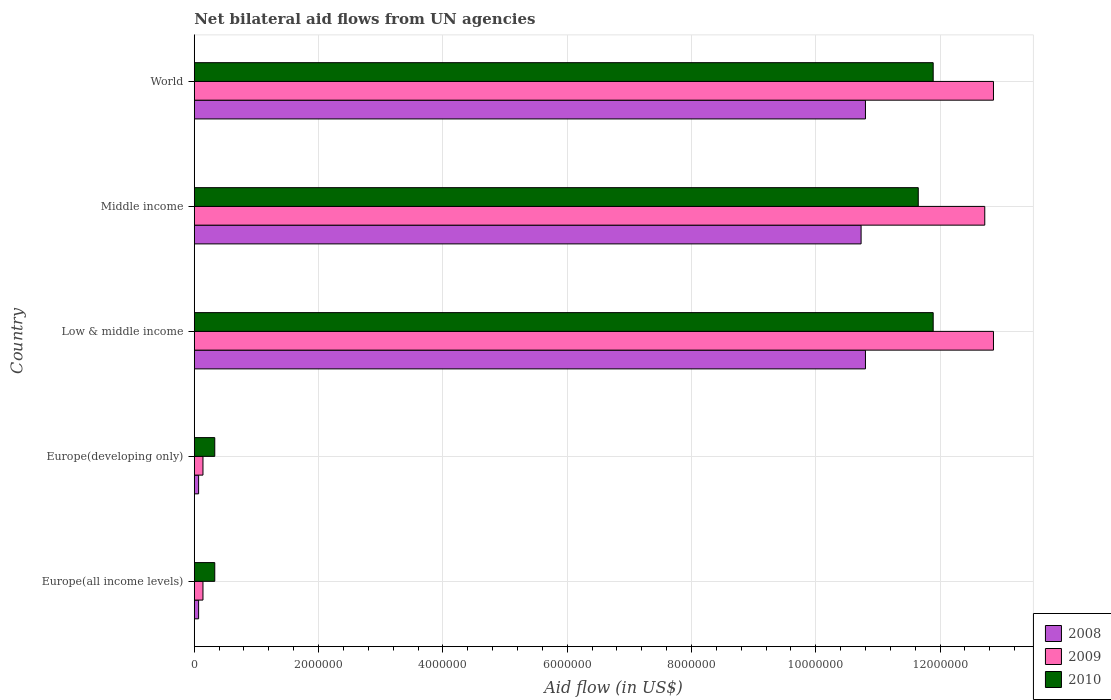How many different coloured bars are there?
Offer a very short reply. 3. Are the number of bars on each tick of the Y-axis equal?
Offer a terse response. Yes. How many bars are there on the 4th tick from the top?
Offer a terse response. 3. How many bars are there on the 4th tick from the bottom?
Give a very brief answer. 3. What is the label of the 4th group of bars from the top?
Your answer should be compact. Europe(developing only). In how many cases, is the number of bars for a given country not equal to the number of legend labels?
Provide a short and direct response. 0. What is the net bilateral aid flow in 2010 in Low & middle income?
Provide a short and direct response. 1.19e+07. Across all countries, what is the maximum net bilateral aid flow in 2009?
Your answer should be compact. 1.29e+07. Across all countries, what is the minimum net bilateral aid flow in 2009?
Provide a short and direct response. 1.40e+05. In which country was the net bilateral aid flow in 2008 maximum?
Your answer should be compact. Low & middle income. In which country was the net bilateral aid flow in 2010 minimum?
Make the answer very short. Europe(all income levels). What is the total net bilateral aid flow in 2009 in the graph?
Your response must be concise. 3.87e+07. What is the difference between the net bilateral aid flow in 2008 in Europe(all income levels) and that in Europe(developing only)?
Keep it short and to the point. 0. What is the difference between the net bilateral aid flow in 2009 in Europe(all income levels) and the net bilateral aid flow in 2008 in Low & middle income?
Provide a succinct answer. -1.07e+07. What is the average net bilateral aid flow in 2009 per country?
Your response must be concise. 7.74e+06. What is the difference between the net bilateral aid flow in 2008 and net bilateral aid flow in 2010 in World?
Provide a succinct answer. -1.09e+06. In how many countries, is the net bilateral aid flow in 2008 greater than 11200000 US$?
Provide a short and direct response. 0. What is the ratio of the net bilateral aid flow in 2009 in Europe(developing only) to that in Low & middle income?
Make the answer very short. 0.01. Is the difference between the net bilateral aid flow in 2008 in Europe(all income levels) and Europe(developing only) greater than the difference between the net bilateral aid flow in 2010 in Europe(all income levels) and Europe(developing only)?
Give a very brief answer. No. What is the difference between the highest and the second highest net bilateral aid flow in 2010?
Offer a very short reply. 0. What is the difference between the highest and the lowest net bilateral aid flow in 2009?
Your answer should be compact. 1.27e+07. In how many countries, is the net bilateral aid flow in 2008 greater than the average net bilateral aid flow in 2008 taken over all countries?
Offer a very short reply. 3. What does the 2nd bar from the top in Low & middle income represents?
Your answer should be compact. 2009. What does the 1st bar from the bottom in Middle income represents?
Give a very brief answer. 2008. How many bars are there?
Make the answer very short. 15. Are all the bars in the graph horizontal?
Make the answer very short. Yes. Are the values on the major ticks of X-axis written in scientific E-notation?
Make the answer very short. No. Does the graph contain grids?
Your answer should be compact. Yes. Where does the legend appear in the graph?
Your answer should be very brief. Bottom right. What is the title of the graph?
Keep it short and to the point. Net bilateral aid flows from UN agencies. Does "1976" appear as one of the legend labels in the graph?
Your answer should be very brief. No. What is the label or title of the X-axis?
Provide a succinct answer. Aid flow (in US$). What is the Aid flow (in US$) in 2008 in Europe(all income levels)?
Your answer should be compact. 7.00e+04. What is the Aid flow (in US$) of 2009 in Europe(all income levels)?
Ensure brevity in your answer.  1.40e+05. What is the Aid flow (in US$) of 2010 in Europe(developing only)?
Offer a very short reply. 3.30e+05. What is the Aid flow (in US$) of 2008 in Low & middle income?
Give a very brief answer. 1.08e+07. What is the Aid flow (in US$) in 2009 in Low & middle income?
Your response must be concise. 1.29e+07. What is the Aid flow (in US$) of 2010 in Low & middle income?
Make the answer very short. 1.19e+07. What is the Aid flow (in US$) in 2008 in Middle income?
Make the answer very short. 1.07e+07. What is the Aid flow (in US$) of 2009 in Middle income?
Make the answer very short. 1.27e+07. What is the Aid flow (in US$) of 2010 in Middle income?
Offer a terse response. 1.16e+07. What is the Aid flow (in US$) in 2008 in World?
Make the answer very short. 1.08e+07. What is the Aid flow (in US$) in 2009 in World?
Provide a short and direct response. 1.29e+07. What is the Aid flow (in US$) of 2010 in World?
Provide a short and direct response. 1.19e+07. Across all countries, what is the maximum Aid flow (in US$) in 2008?
Your answer should be very brief. 1.08e+07. Across all countries, what is the maximum Aid flow (in US$) of 2009?
Provide a short and direct response. 1.29e+07. Across all countries, what is the maximum Aid flow (in US$) in 2010?
Make the answer very short. 1.19e+07. Across all countries, what is the minimum Aid flow (in US$) of 2008?
Your response must be concise. 7.00e+04. Across all countries, what is the minimum Aid flow (in US$) in 2010?
Offer a very short reply. 3.30e+05. What is the total Aid flow (in US$) of 2008 in the graph?
Offer a very short reply. 3.25e+07. What is the total Aid flow (in US$) of 2009 in the graph?
Your response must be concise. 3.87e+07. What is the total Aid flow (in US$) in 2010 in the graph?
Your answer should be very brief. 3.61e+07. What is the difference between the Aid flow (in US$) of 2008 in Europe(all income levels) and that in Low & middle income?
Give a very brief answer. -1.07e+07. What is the difference between the Aid flow (in US$) in 2009 in Europe(all income levels) and that in Low & middle income?
Your answer should be compact. -1.27e+07. What is the difference between the Aid flow (in US$) in 2010 in Europe(all income levels) and that in Low & middle income?
Offer a very short reply. -1.16e+07. What is the difference between the Aid flow (in US$) of 2008 in Europe(all income levels) and that in Middle income?
Give a very brief answer. -1.07e+07. What is the difference between the Aid flow (in US$) of 2009 in Europe(all income levels) and that in Middle income?
Offer a terse response. -1.26e+07. What is the difference between the Aid flow (in US$) in 2010 in Europe(all income levels) and that in Middle income?
Give a very brief answer. -1.13e+07. What is the difference between the Aid flow (in US$) of 2008 in Europe(all income levels) and that in World?
Provide a short and direct response. -1.07e+07. What is the difference between the Aid flow (in US$) in 2009 in Europe(all income levels) and that in World?
Give a very brief answer. -1.27e+07. What is the difference between the Aid flow (in US$) of 2010 in Europe(all income levels) and that in World?
Keep it short and to the point. -1.16e+07. What is the difference between the Aid flow (in US$) in 2008 in Europe(developing only) and that in Low & middle income?
Your response must be concise. -1.07e+07. What is the difference between the Aid flow (in US$) in 2009 in Europe(developing only) and that in Low & middle income?
Provide a short and direct response. -1.27e+07. What is the difference between the Aid flow (in US$) in 2010 in Europe(developing only) and that in Low & middle income?
Provide a short and direct response. -1.16e+07. What is the difference between the Aid flow (in US$) in 2008 in Europe(developing only) and that in Middle income?
Your answer should be very brief. -1.07e+07. What is the difference between the Aid flow (in US$) in 2009 in Europe(developing only) and that in Middle income?
Provide a succinct answer. -1.26e+07. What is the difference between the Aid flow (in US$) in 2010 in Europe(developing only) and that in Middle income?
Provide a short and direct response. -1.13e+07. What is the difference between the Aid flow (in US$) in 2008 in Europe(developing only) and that in World?
Offer a very short reply. -1.07e+07. What is the difference between the Aid flow (in US$) of 2009 in Europe(developing only) and that in World?
Make the answer very short. -1.27e+07. What is the difference between the Aid flow (in US$) in 2010 in Europe(developing only) and that in World?
Offer a very short reply. -1.16e+07. What is the difference between the Aid flow (in US$) in 2008 in Low & middle income and that in Middle income?
Your response must be concise. 7.00e+04. What is the difference between the Aid flow (in US$) in 2009 in Low & middle income and that in Middle income?
Ensure brevity in your answer.  1.40e+05. What is the difference between the Aid flow (in US$) in 2010 in Low & middle income and that in Middle income?
Your answer should be very brief. 2.40e+05. What is the difference between the Aid flow (in US$) of 2009 in Low & middle income and that in World?
Your answer should be very brief. 0. What is the difference between the Aid flow (in US$) in 2010 in Low & middle income and that in World?
Keep it short and to the point. 0. What is the difference between the Aid flow (in US$) of 2008 in Middle income and that in World?
Ensure brevity in your answer.  -7.00e+04. What is the difference between the Aid flow (in US$) in 2008 in Europe(all income levels) and the Aid flow (in US$) in 2009 in Europe(developing only)?
Your response must be concise. -7.00e+04. What is the difference between the Aid flow (in US$) in 2008 in Europe(all income levels) and the Aid flow (in US$) in 2009 in Low & middle income?
Offer a terse response. -1.28e+07. What is the difference between the Aid flow (in US$) of 2008 in Europe(all income levels) and the Aid flow (in US$) of 2010 in Low & middle income?
Offer a very short reply. -1.18e+07. What is the difference between the Aid flow (in US$) in 2009 in Europe(all income levels) and the Aid flow (in US$) in 2010 in Low & middle income?
Offer a very short reply. -1.18e+07. What is the difference between the Aid flow (in US$) of 2008 in Europe(all income levels) and the Aid flow (in US$) of 2009 in Middle income?
Ensure brevity in your answer.  -1.26e+07. What is the difference between the Aid flow (in US$) in 2008 in Europe(all income levels) and the Aid flow (in US$) in 2010 in Middle income?
Make the answer very short. -1.16e+07. What is the difference between the Aid flow (in US$) in 2009 in Europe(all income levels) and the Aid flow (in US$) in 2010 in Middle income?
Provide a succinct answer. -1.15e+07. What is the difference between the Aid flow (in US$) of 2008 in Europe(all income levels) and the Aid flow (in US$) of 2009 in World?
Your response must be concise. -1.28e+07. What is the difference between the Aid flow (in US$) in 2008 in Europe(all income levels) and the Aid flow (in US$) in 2010 in World?
Offer a terse response. -1.18e+07. What is the difference between the Aid flow (in US$) of 2009 in Europe(all income levels) and the Aid flow (in US$) of 2010 in World?
Your answer should be very brief. -1.18e+07. What is the difference between the Aid flow (in US$) of 2008 in Europe(developing only) and the Aid flow (in US$) of 2009 in Low & middle income?
Make the answer very short. -1.28e+07. What is the difference between the Aid flow (in US$) of 2008 in Europe(developing only) and the Aid flow (in US$) of 2010 in Low & middle income?
Make the answer very short. -1.18e+07. What is the difference between the Aid flow (in US$) in 2009 in Europe(developing only) and the Aid flow (in US$) in 2010 in Low & middle income?
Your response must be concise. -1.18e+07. What is the difference between the Aid flow (in US$) in 2008 in Europe(developing only) and the Aid flow (in US$) in 2009 in Middle income?
Offer a very short reply. -1.26e+07. What is the difference between the Aid flow (in US$) of 2008 in Europe(developing only) and the Aid flow (in US$) of 2010 in Middle income?
Your answer should be very brief. -1.16e+07. What is the difference between the Aid flow (in US$) of 2009 in Europe(developing only) and the Aid flow (in US$) of 2010 in Middle income?
Keep it short and to the point. -1.15e+07. What is the difference between the Aid flow (in US$) in 2008 in Europe(developing only) and the Aid flow (in US$) in 2009 in World?
Keep it short and to the point. -1.28e+07. What is the difference between the Aid flow (in US$) of 2008 in Europe(developing only) and the Aid flow (in US$) of 2010 in World?
Provide a succinct answer. -1.18e+07. What is the difference between the Aid flow (in US$) in 2009 in Europe(developing only) and the Aid flow (in US$) in 2010 in World?
Provide a short and direct response. -1.18e+07. What is the difference between the Aid flow (in US$) of 2008 in Low & middle income and the Aid flow (in US$) of 2009 in Middle income?
Your answer should be compact. -1.92e+06. What is the difference between the Aid flow (in US$) of 2008 in Low & middle income and the Aid flow (in US$) of 2010 in Middle income?
Give a very brief answer. -8.50e+05. What is the difference between the Aid flow (in US$) of 2009 in Low & middle income and the Aid flow (in US$) of 2010 in Middle income?
Provide a short and direct response. 1.21e+06. What is the difference between the Aid flow (in US$) of 2008 in Low & middle income and the Aid flow (in US$) of 2009 in World?
Your answer should be very brief. -2.06e+06. What is the difference between the Aid flow (in US$) in 2008 in Low & middle income and the Aid flow (in US$) in 2010 in World?
Your answer should be very brief. -1.09e+06. What is the difference between the Aid flow (in US$) in 2009 in Low & middle income and the Aid flow (in US$) in 2010 in World?
Your answer should be very brief. 9.70e+05. What is the difference between the Aid flow (in US$) of 2008 in Middle income and the Aid flow (in US$) of 2009 in World?
Give a very brief answer. -2.13e+06. What is the difference between the Aid flow (in US$) in 2008 in Middle income and the Aid flow (in US$) in 2010 in World?
Your answer should be very brief. -1.16e+06. What is the difference between the Aid flow (in US$) of 2009 in Middle income and the Aid flow (in US$) of 2010 in World?
Provide a succinct answer. 8.30e+05. What is the average Aid flow (in US$) in 2008 per country?
Ensure brevity in your answer.  6.49e+06. What is the average Aid flow (in US$) of 2009 per country?
Give a very brief answer. 7.74e+06. What is the average Aid flow (in US$) of 2010 per country?
Offer a very short reply. 7.22e+06. What is the difference between the Aid flow (in US$) in 2009 and Aid flow (in US$) in 2010 in Europe(all income levels)?
Your answer should be compact. -1.90e+05. What is the difference between the Aid flow (in US$) in 2008 and Aid flow (in US$) in 2010 in Europe(developing only)?
Give a very brief answer. -2.60e+05. What is the difference between the Aid flow (in US$) in 2009 and Aid flow (in US$) in 2010 in Europe(developing only)?
Give a very brief answer. -1.90e+05. What is the difference between the Aid flow (in US$) of 2008 and Aid flow (in US$) of 2009 in Low & middle income?
Offer a terse response. -2.06e+06. What is the difference between the Aid flow (in US$) of 2008 and Aid flow (in US$) of 2010 in Low & middle income?
Your answer should be compact. -1.09e+06. What is the difference between the Aid flow (in US$) in 2009 and Aid flow (in US$) in 2010 in Low & middle income?
Your response must be concise. 9.70e+05. What is the difference between the Aid flow (in US$) of 2008 and Aid flow (in US$) of 2009 in Middle income?
Your response must be concise. -1.99e+06. What is the difference between the Aid flow (in US$) of 2008 and Aid flow (in US$) of 2010 in Middle income?
Your answer should be compact. -9.20e+05. What is the difference between the Aid flow (in US$) in 2009 and Aid flow (in US$) in 2010 in Middle income?
Provide a short and direct response. 1.07e+06. What is the difference between the Aid flow (in US$) of 2008 and Aid flow (in US$) of 2009 in World?
Make the answer very short. -2.06e+06. What is the difference between the Aid flow (in US$) in 2008 and Aid flow (in US$) in 2010 in World?
Offer a very short reply. -1.09e+06. What is the difference between the Aid flow (in US$) of 2009 and Aid flow (in US$) of 2010 in World?
Your answer should be very brief. 9.70e+05. What is the ratio of the Aid flow (in US$) of 2009 in Europe(all income levels) to that in Europe(developing only)?
Offer a very short reply. 1. What is the ratio of the Aid flow (in US$) in 2008 in Europe(all income levels) to that in Low & middle income?
Your response must be concise. 0.01. What is the ratio of the Aid flow (in US$) in 2009 in Europe(all income levels) to that in Low & middle income?
Your answer should be very brief. 0.01. What is the ratio of the Aid flow (in US$) of 2010 in Europe(all income levels) to that in Low & middle income?
Provide a succinct answer. 0.03. What is the ratio of the Aid flow (in US$) of 2008 in Europe(all income levels) to that in Middle income?
Offer a terse response. 0.01. What is the ratio of the Aid flow (in US$) in 2009 in Europe(all income levels) to that in Middle income?
Make the answer very short. 0.01. What is the ratio of the Aid flow (in US$) of 2010 in Europe(all income levels) to that in Middle income?
Give a very brief answer. 0.03. What is the ratio of the Aid flow (in US$) in 2008 in Europe(all income levels) to that in World?
Your answer should be very brief. 0.01. What is the ratio of the Aid flow (in US$) of 2009 in Europe(all income levels) to that in World?
Give a very brief answer. 0.01. What is the ratio of the Aid flow (in US$) in 2010 in Europe(all income levels) to that in World?
Your answer should be very brief. 0.03. What is the ratio of the Aid flow (in US$) of 2008 in Europe(developing only) to that in Low & middle income?
Offer a terse response. 0.01. What is the ratio of the Aid flow (in US$) of 2009 in Europe(developing only) to that in Low & middle income?
Provide a short and direct response. 0.01. What is the ratio of the Aid flow (in US$) of 2010 in Europe(developing only) to that in Low & middle income?
Your response must be concise. 0.03. What is the ratio of the Aid flow (in US$) of 2008 in Europe(developing only) to that in Middle income?
Your answer should be very brief. 0.01. What is the ratio of the Aid flow (in US$) in 2009 in Europe(developing only) to that in Middle income?
Provide a short and direct response. 0.01. What is the ratio of the Aid flow (in US$) in 2010 in Europe(developing only) to that in Middle income?
Provide a succinct answer. 0.03. What is the ratio of the Aid flow (in US$) of 2008 in Europe(developing only) to that in World?
Offer a very short reply. 0.01. What is the ratio of the Aid flow (in US$) of 2009 in Europe(developing only) to that in World?
Your answer should be compact. 0.01. What is the ratio of the Aid flow (in US$) of 2010 in Europe(developing only) to that in World?
Provide a succinct answer. 0.03. What is the ratio of the Aid flow (in US$) in 2008 in Low & middle income to that in Middle income?
Provide a short and direct response. 1.01. What is the ratio of the Aid flow (in US$) in 2010 in Low & middle income to that in Middle income?
Make the answer very short. 1.02. What is the ratio of the Aid flow (in US$) of 2009 in Low & middle income to that in World?
Give a very brief answer. 1. What is the ratio of the Aid flow (in US$) in 2008 in Middle income to that in World?
Make the answer very short. 0.99. What is the ratio of the Aid flow (in US$) in 2010 in Middle income to that in World?
Offer a terse response. 0.98. What is the difference between the highest and the lowest Aid flow (in US$) in 2008?
Make the answer very short. 1.07e+07. What is the difference between the highest and the lowest Aid flow (in US$) in 2009?
Give a very brief answer. 1.27e+07. What is the difference between the highest and the lowest Aid flow (in US$) of 2010?
Your answer should be very brief. 1.16e+07. 